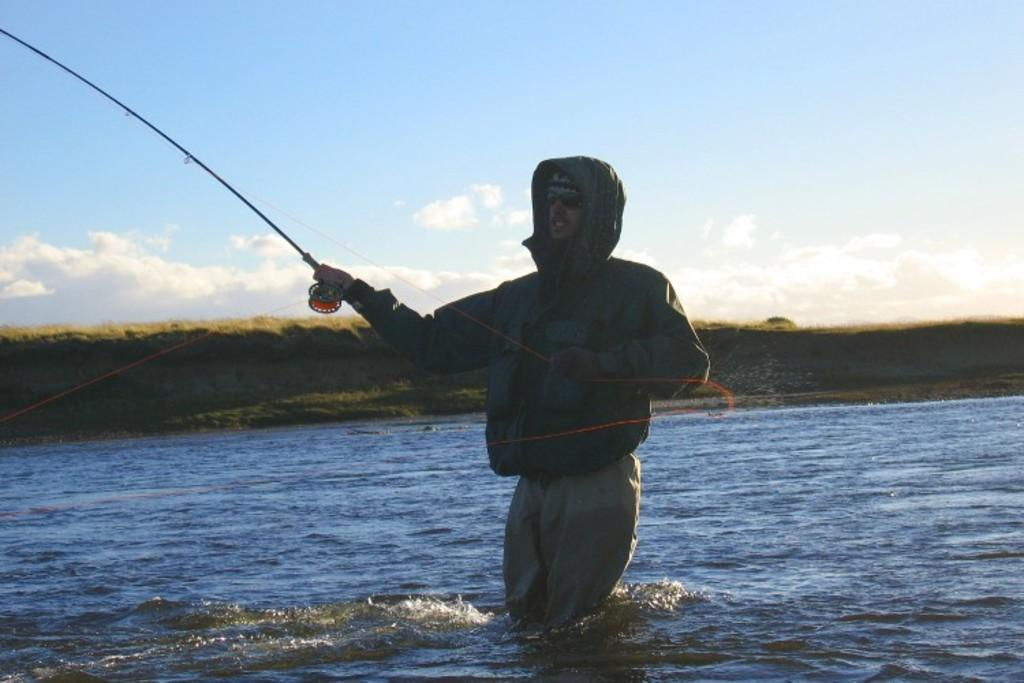What is the man in the image doing? The man is standing in the water. What is the man holding in the image? The man is holding a fishing rod. What can be seen in the background of the image? There is a small mountain in the background of the image. What type of food is the man preparing in the image? There is no indication in the image that the man is preparing food; he is holding a fishing rod. Can you see any quince trees in the image? There are no quince trees present in the image. 